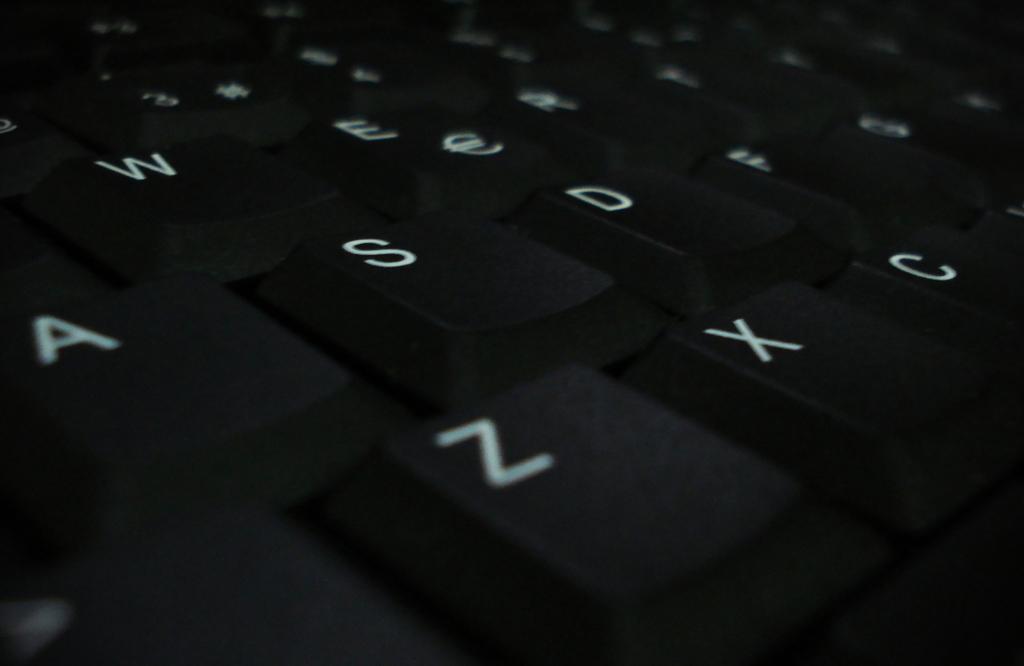What key is below the "a" key?
Your response must be concise. Z. How many keys are on the last row?
Offer a terse response. Answering does not require reading text in the image. 